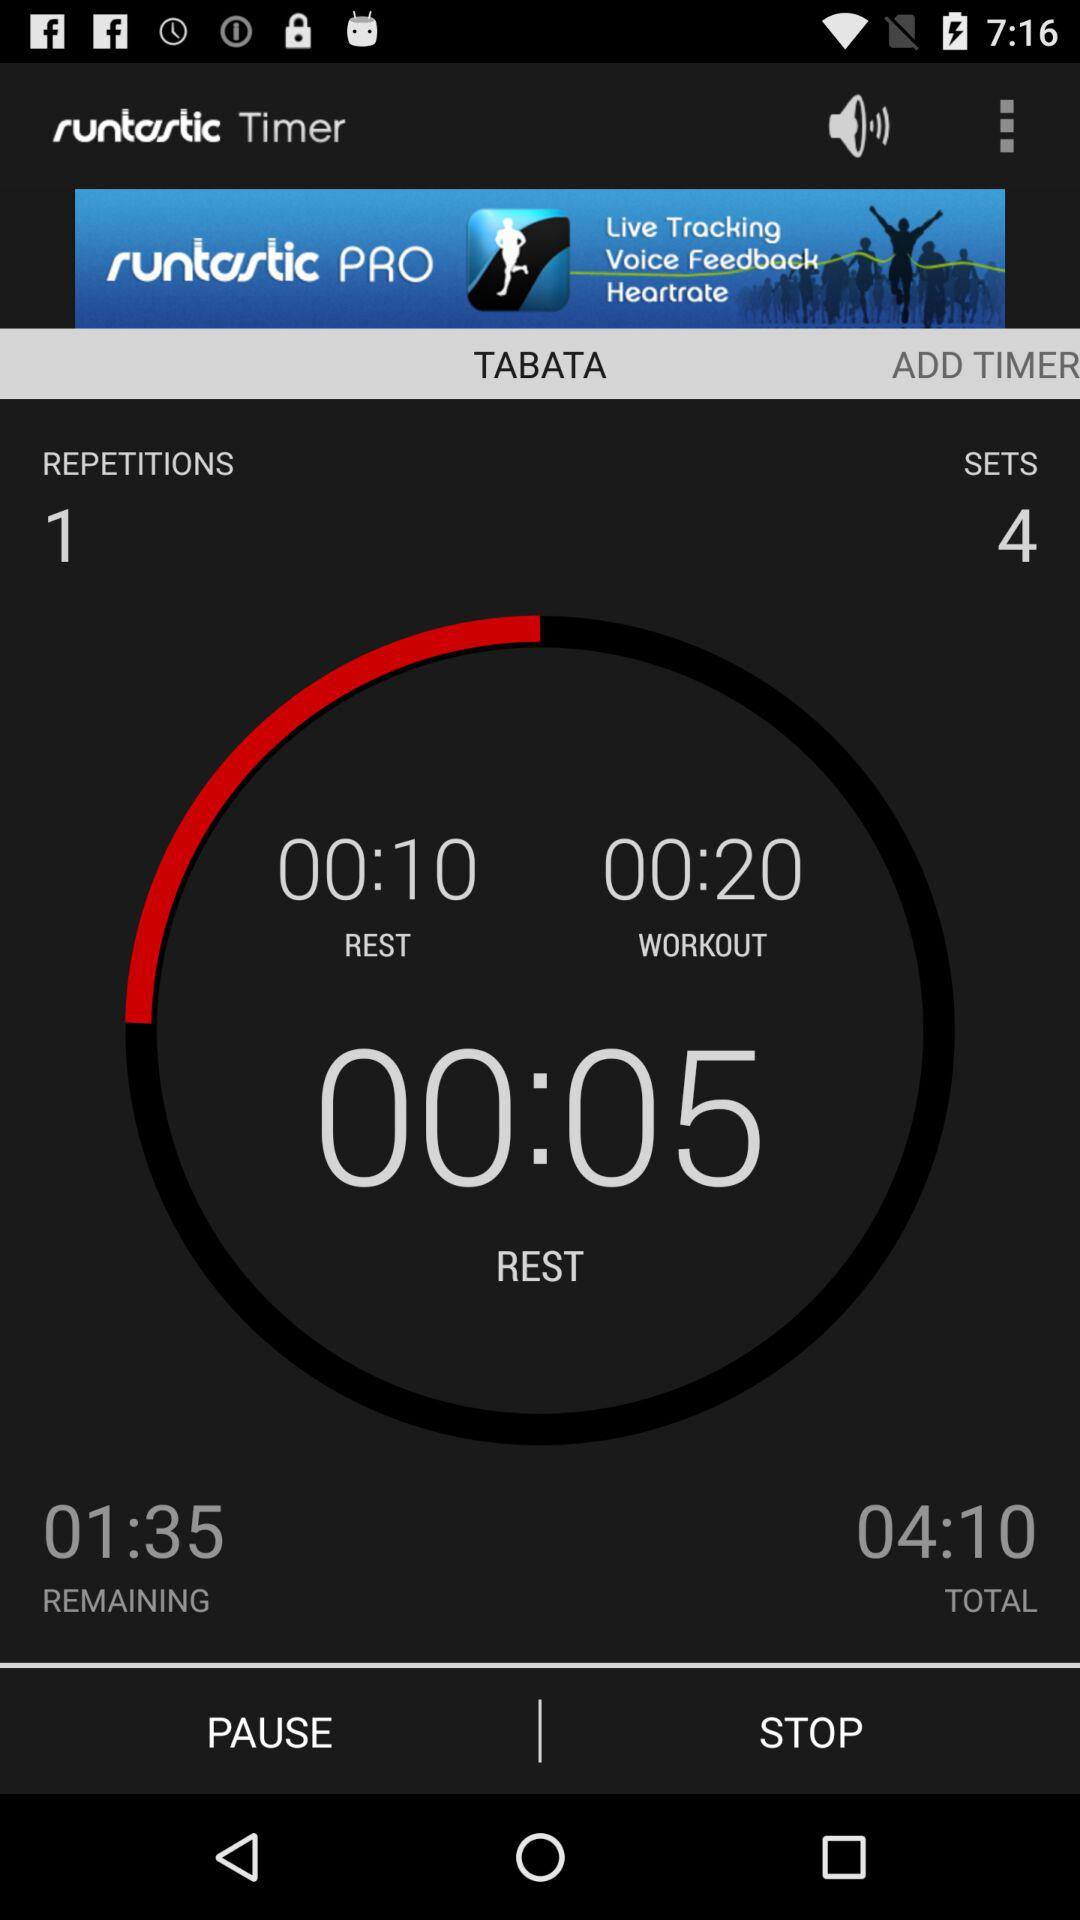How many sets are there?
Answer the question using a single word or phrase. 4 